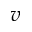Convert formula to latex. <formula><loc_0><loc_0><loc_500><loc_500>v</formula> 